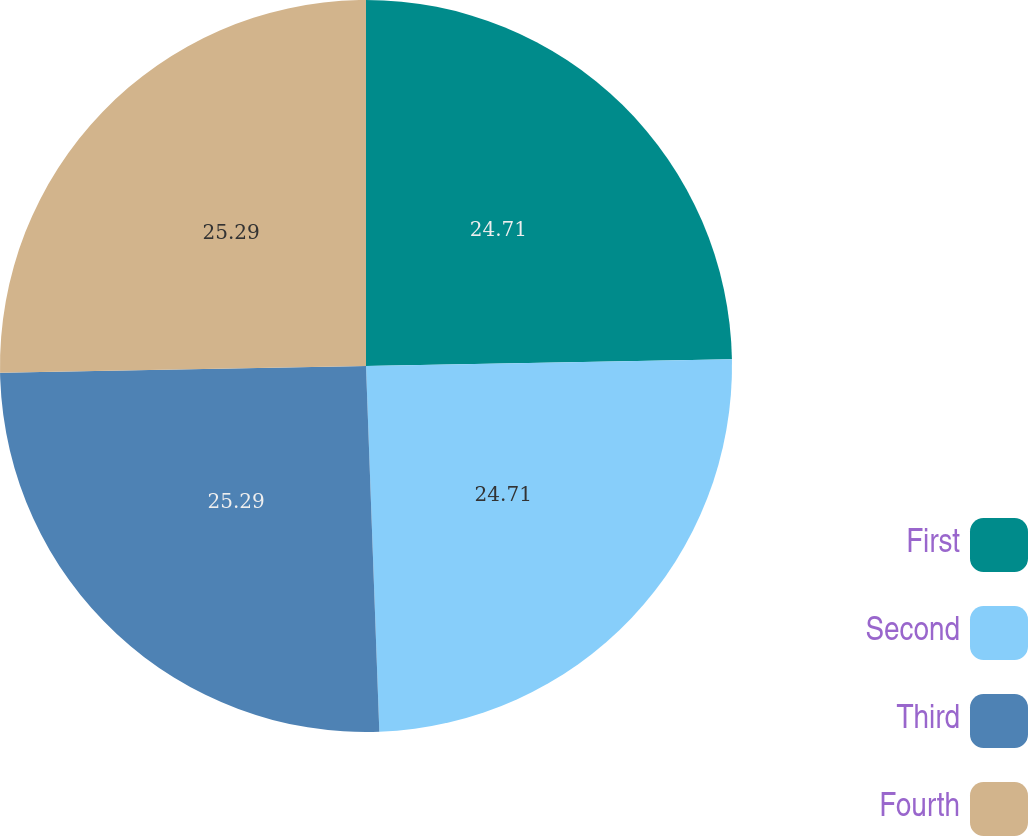<chart> <loc_0><loc_0><loc_500><loc_500><pie_chart><fcel>First<fcel>Second<fcel>Third<fcel>Fourth<nl><fcel>24.71%<fcel>24.71%<fcel>25.29%<fcel>25.29%<nl></chart> 